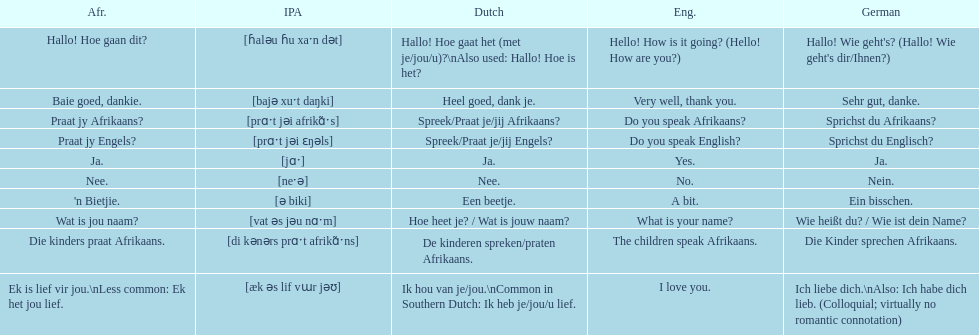How do you say 'yes' in afrikaans? Ja. 